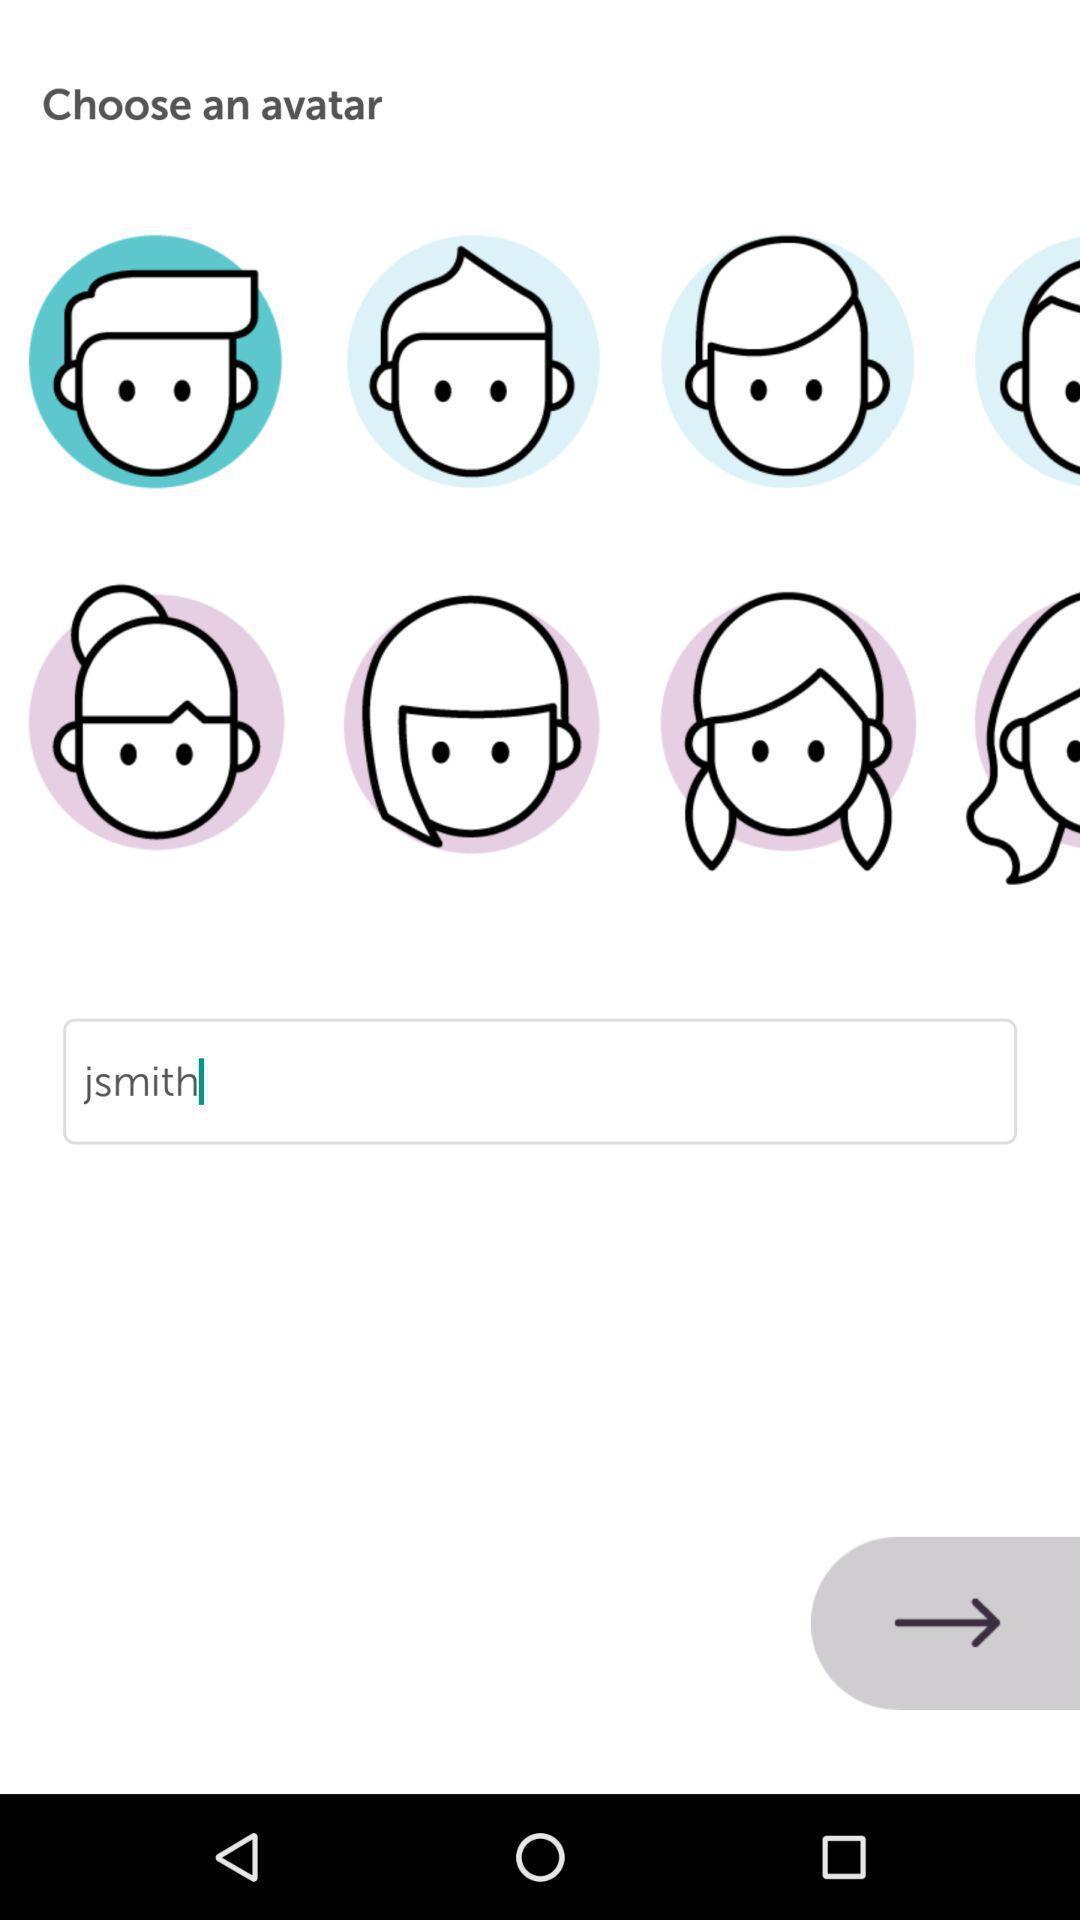What can you discern from this picture? Screen displaying multiple animated emoji icons. 